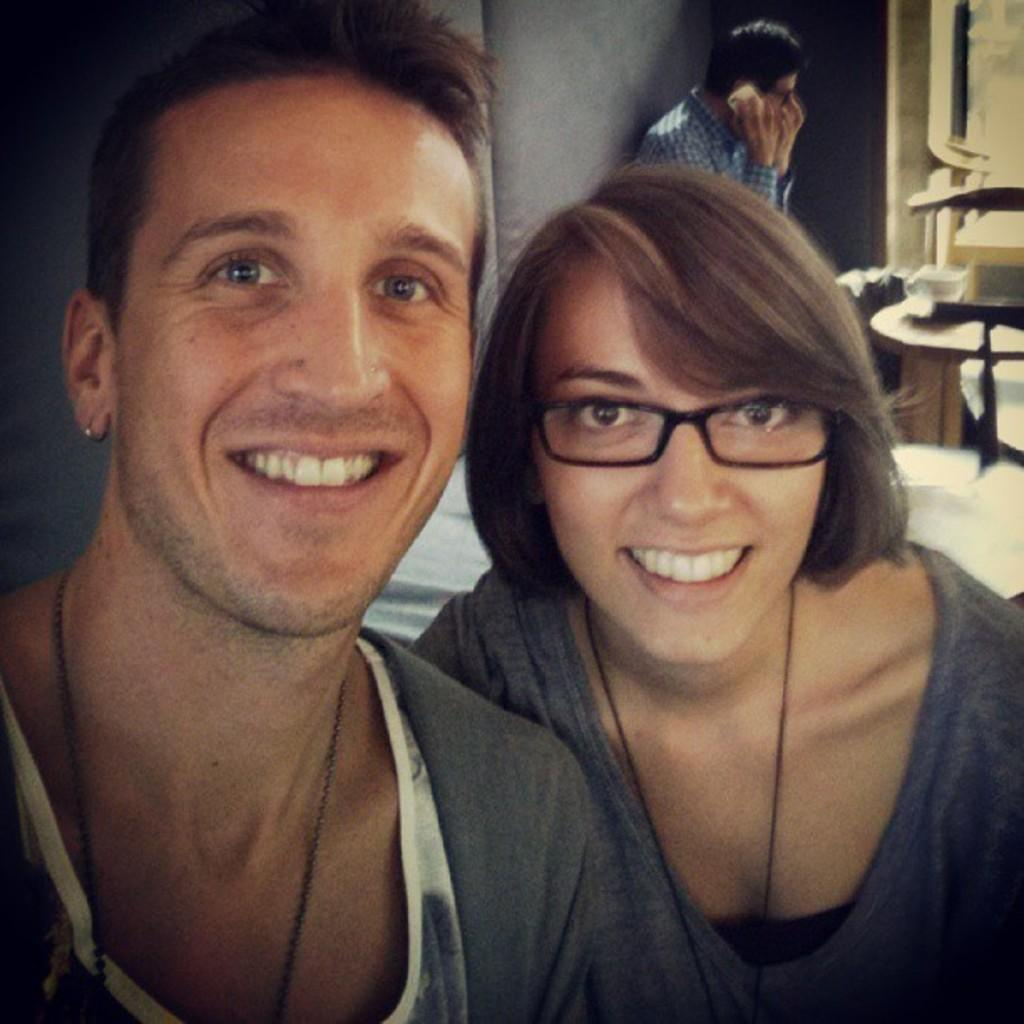How many people are in the image? There are three people in the image. What are the expressions of the man and the woman in the image? Both the man and the woman are smiling. What is the other man in the image doing? The other man is sitting and speaking on a mobile phone. What type of lizards can be seen in the locket around the woman's neck in the image? There are no lizards or lockets present in the image. What statement is the man making on the mobile phone in the image? We cannot determine the content of the conversation from the image alone, as it only shows the man speaking on the phone. 